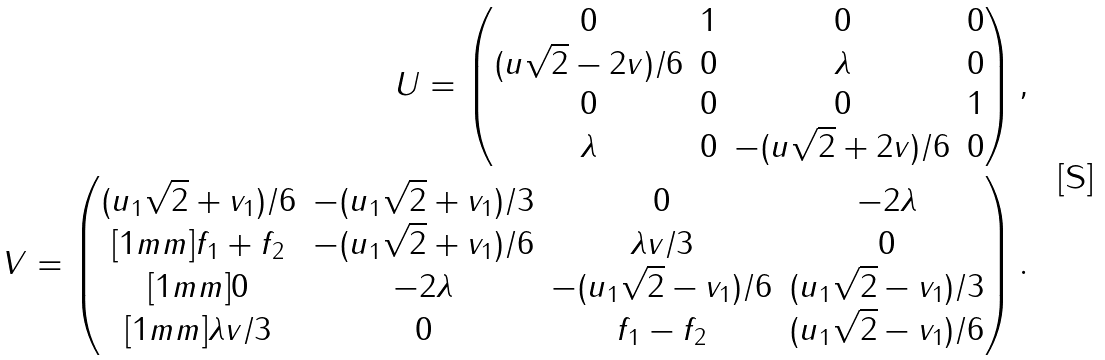Convert formula to latex. <formula><loc_0><loc_0><loc_500><loc_500>U = \begin{pmatrix} 0 & 1 & 0 & 0 \\ ( u \sqrt { 2 } - 2 v ) / 6 & 0 & \lambda & 0 \\ 0 & 0 & 0 & 1 \\ \lambda & 0 & - ( u \sqrt { 2 } + 2 v ) / 6 & 0 \end{pmatrix} , \\ V = \begin{pmatrix} ( u _ { 1 } \sqrt { 2 } + v _ { 1 } ) / 6 & - ( u _ { 1 } \sqrt { 2 } + v _ { 1 } ) / 3 & 0 & - 2 \lambda \\ [ 1 m m ] f _ { 1 } + f _ { 2 } & - ( u _ { 1 } \sqrt { 2 } + v _ { 1 } ) / 6 & \lambda v / 3 & 0 \\ [ 1 m m ] 0 & - 2 \lambda & - ( u _ { 1 } \sqrt { 2 } - v _ { 1 } ) / 6 & ( u _ { 1 } \sqrt { 2 } - v _ { 1 } ) / 3 \\ [ 1 m m ] \lambda v / 3 & 0 & f _ { 1 } - f _ { 2 } & ( u _ { 1 } \sqrt { 2 } - v _ { 1 } ) / 6 \end{pmatrix} .</formula> 